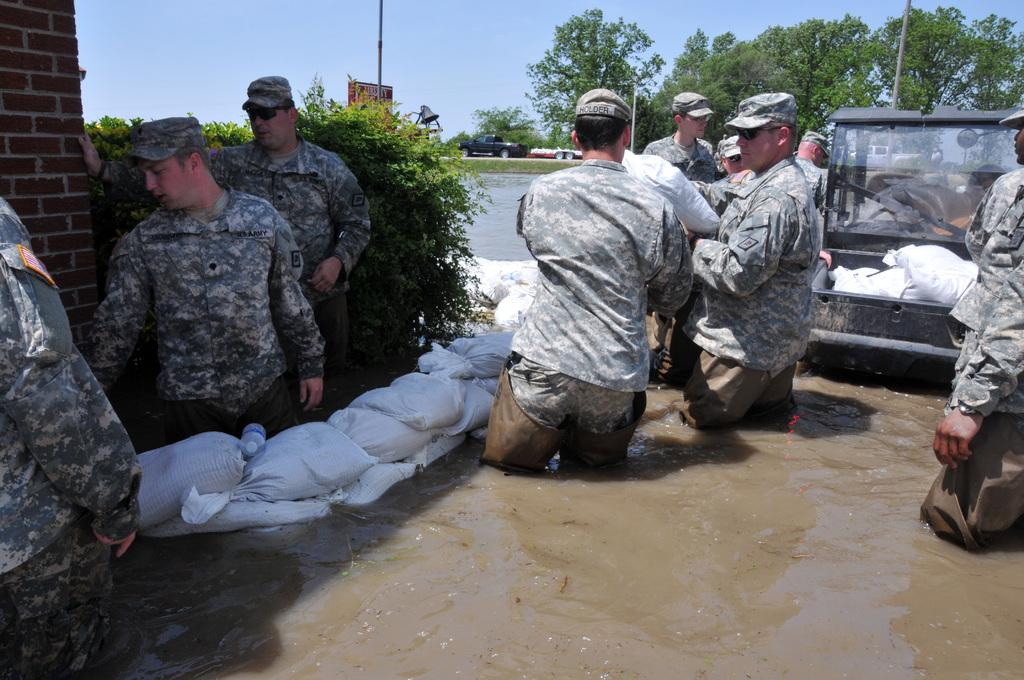What is the primary element visible in the image? There is water in the image. What objects can be seen near the water? There are bags, a bottle, and a vehicle in the image. Are there any people present in the image? Yes, there are people in the image. What type of structure is visible in the background? There is a brick wall in the image. What type of vegetation is present in the image? There are plants and trees in the image. Can you describe the vehicles in the image? There is one vehicle in the image, and there are vehicles in the distance. Where is the nest of the giraffe located in the image? There is no giraffe or nest present in the image. What type of garden can be seen in the image? There is no garden present in the image. 